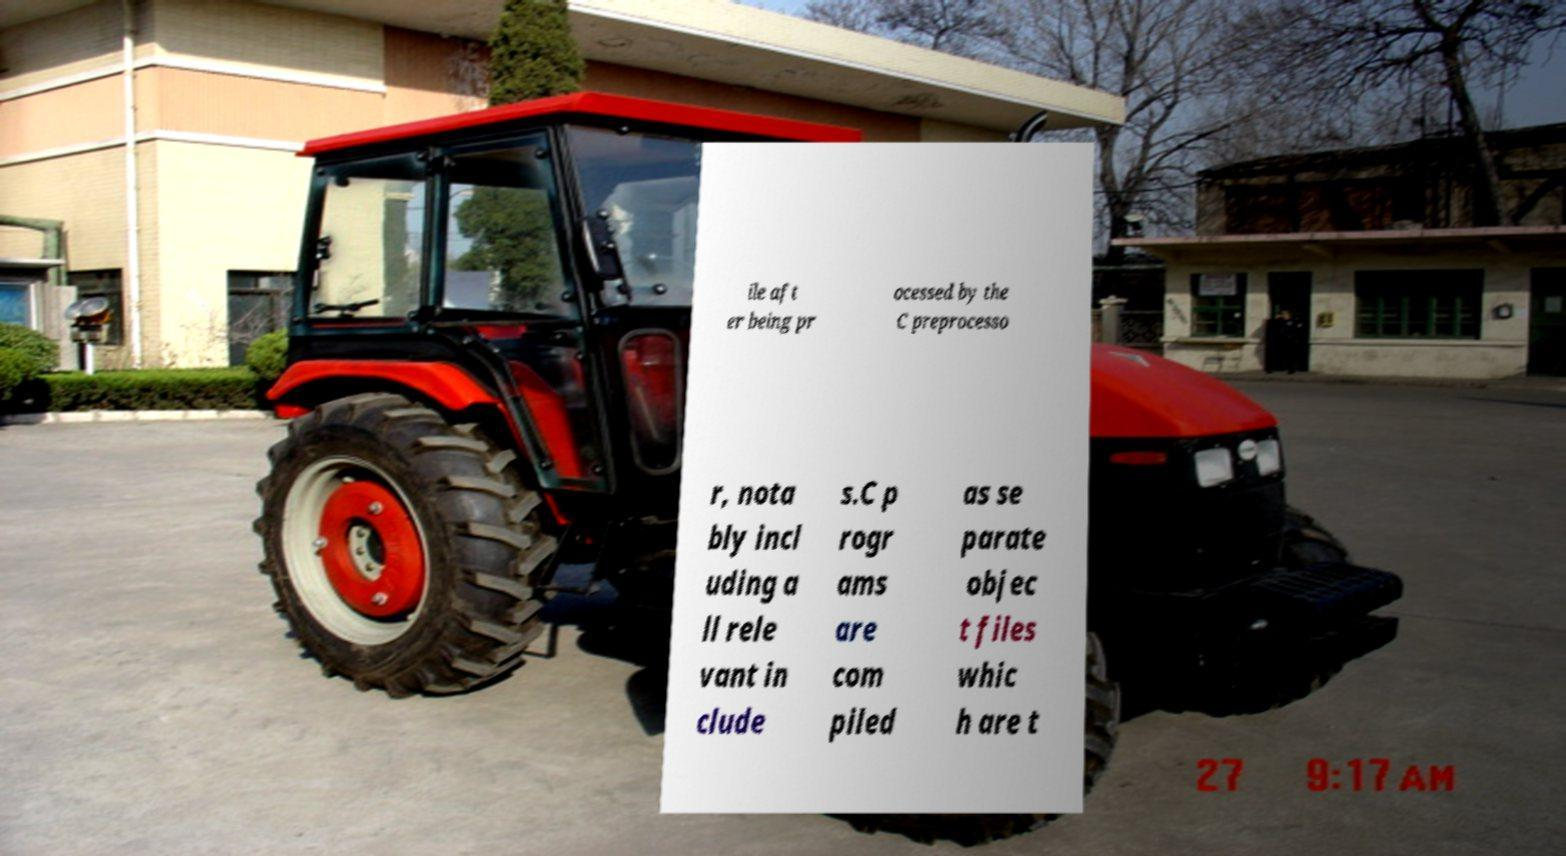What messages or text are displayed in this image? I need them in a readable, typed format. ile aft er being pr ocessed by the C preprocesso r, nota bly incl uding a ll rele vant in clude s.C p rogr ams are com piled as se parate objec t files whic h are t 